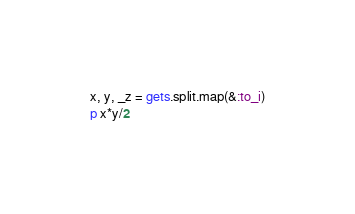Convert code to text. <code><loc_0><loc_0><loc_500><loc_500><_Ruby_>x, y, _z = gets.split.map(&:to_i)
p x*y/2</code> 